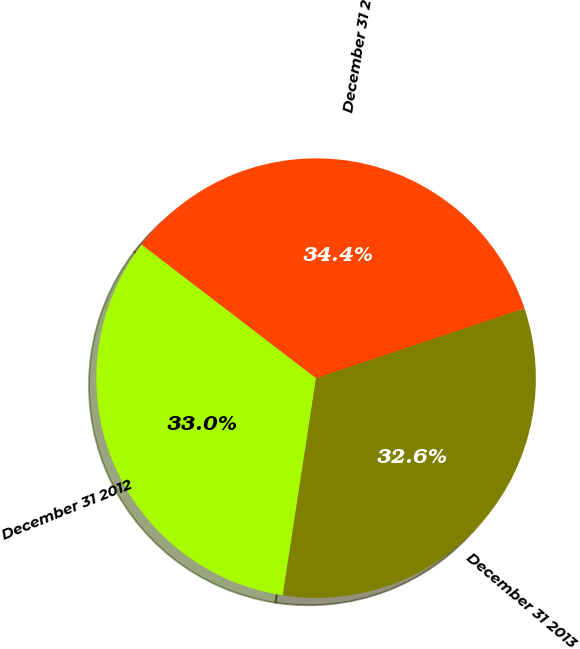Convert chart. <chart><loc_0><loc_0><loc_500><loc_500><pie_chart><fcel>December 31 2012<fcel>December 31 2013<fcel>December 31 2014<nl><fcel>32.99%<fcel>32.57%<fcel>34.45%<nl></chart> 